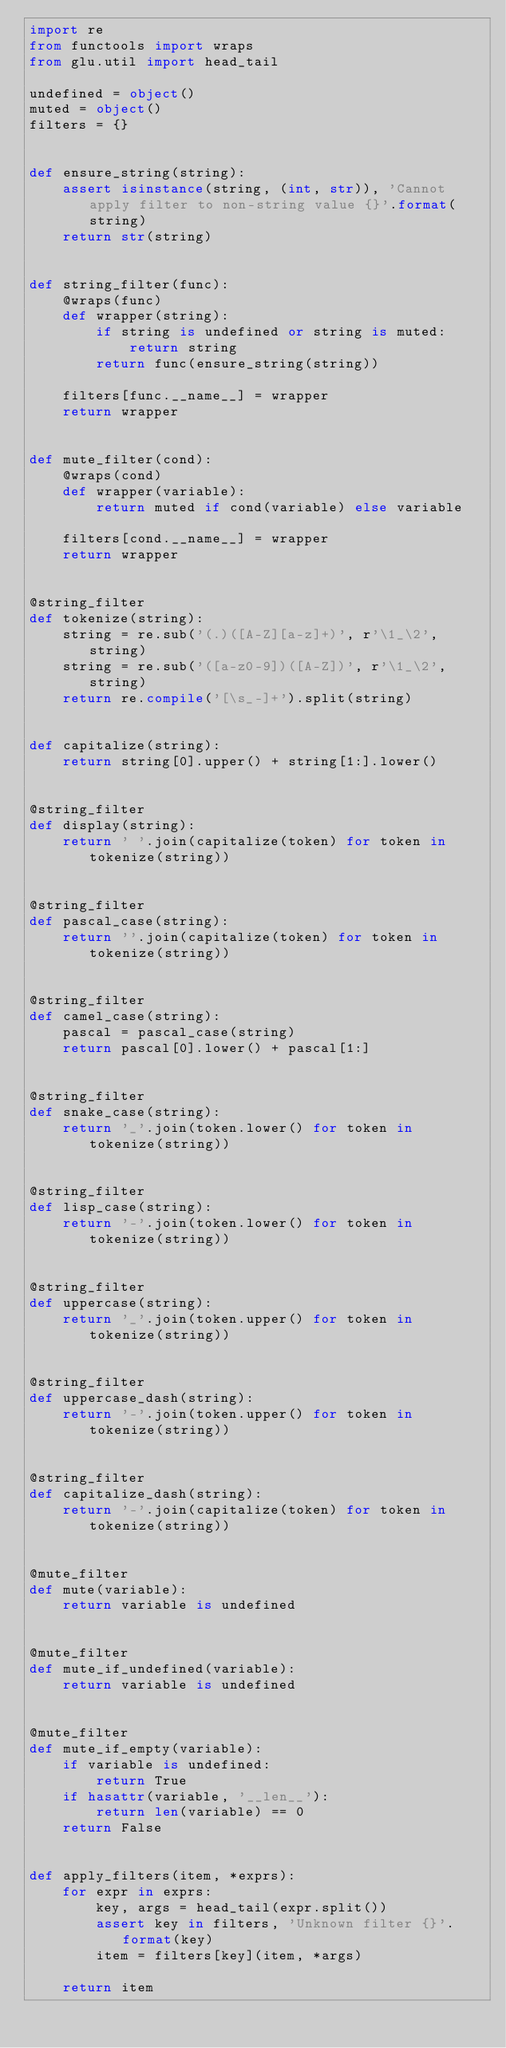Convert code to text. <code><loc_0><loc_0><loc_500><loc_500><_Python_>import re
from functools import wraps
from glu.util import head_tail

undefined = object()
muted = object()
filters = {}


def ensure_string(string):
    assert isinstance(string, (int, str)), 'Cannot apply filter to non-string value {}'.format(string)
    return str(string)


def string_filter(func):
    @wraps(func)
    def wrapper(string):
        if string is undefined or string is muted:
            return string
        return func(ensure_string(string))

    filters[func.__name__] = wrapper
    return wrapper


def mute_filter(cond):
    @wraps(cond)
    def wrapper(variable):
        return muted if cond(variable) else variable

    filters[cond.__name__] = wrapper
    return wrapper


@string_filter
def tokenize(string):
    string = re.sub('(.)([A-Z][a-z]+)', r'\1_\2', string)
    string = re.sub('([a-z0-9])([A-Z])', r'\1_\2', string)
    return re.compile('[\s_-]+').split(string)


def capitalize(string):
    return string[0].upper() + string[1:].lower()


@string_filter
def display(string):
    return ' '.join(capitalize(token) for token in tokenize(string))


@string_filter
def pascal_case(string):
    return ''.join(capitalize(token) for token in tokenize(string))


@string_filter
def camel_case(string):
    pascal = pascal_case(string)
    return pascal[0].lower() + pascal[1:]


@string_filter
def snake_case(string):
    return '_'.join(token.lower() for token in tokenize(string))


@string_filter
def lisp_case(string):
    return '-'.join(token.lower() for token in tokenize(string))


@string_filter
def uppercase(string):
    return '_'.join(token.upper() for token in tokenize(string))


@string_filter
def uppercase_dash(string):
    return '-'.join(token.upper() for token in tokenize(string))


@string_filter
def capitalize_dash(string):
    return '-'.join(capitalize(token) for token in tokenize(string))


@mute_filter
def mute(variable):
    return variable is undefined


@mute_filter
def mute_if_undefined(variable):
    return variable is undefined


@mute_filter
def mute_if_empty(variable):
    if variable is undefined:
        return True
    if hasattr(variable, '__len__'):
        return len(variable) == 0
    return False


def apply_filters(item, *exprs):
    for expr in exprs:
        key, args = head_tail(expr.split())
        assert key in filters, 'Unknown filter {}'.format(key)
        item = filters[key](item, *args)

    return item
</code> 